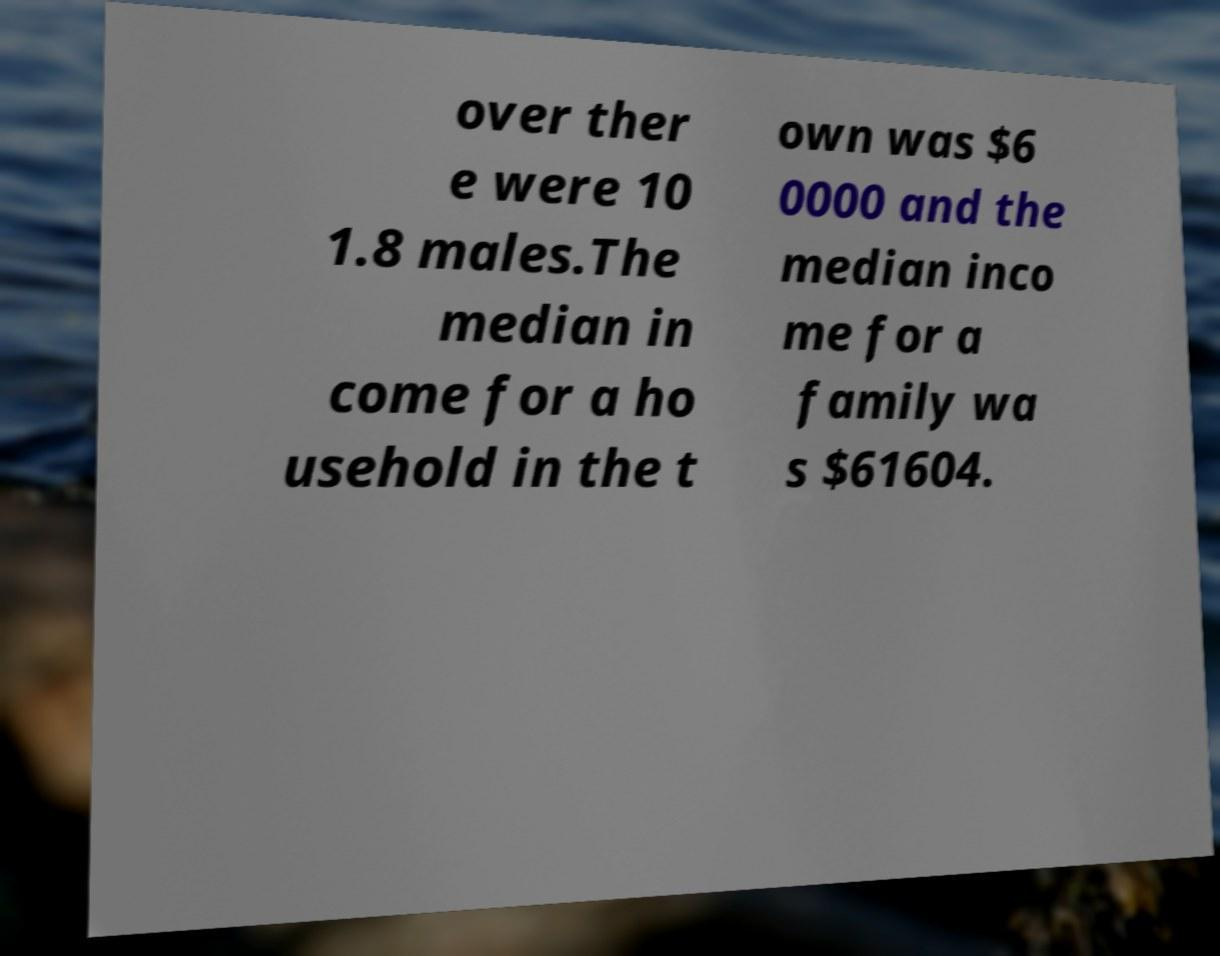Could you assist in decoding the text presented in this image and type it out clearly? over ther e were 10 1.8 males.The median in come for a ho usehold in the t own was $6 0000 and the median inco me for a family wa s $61604. 